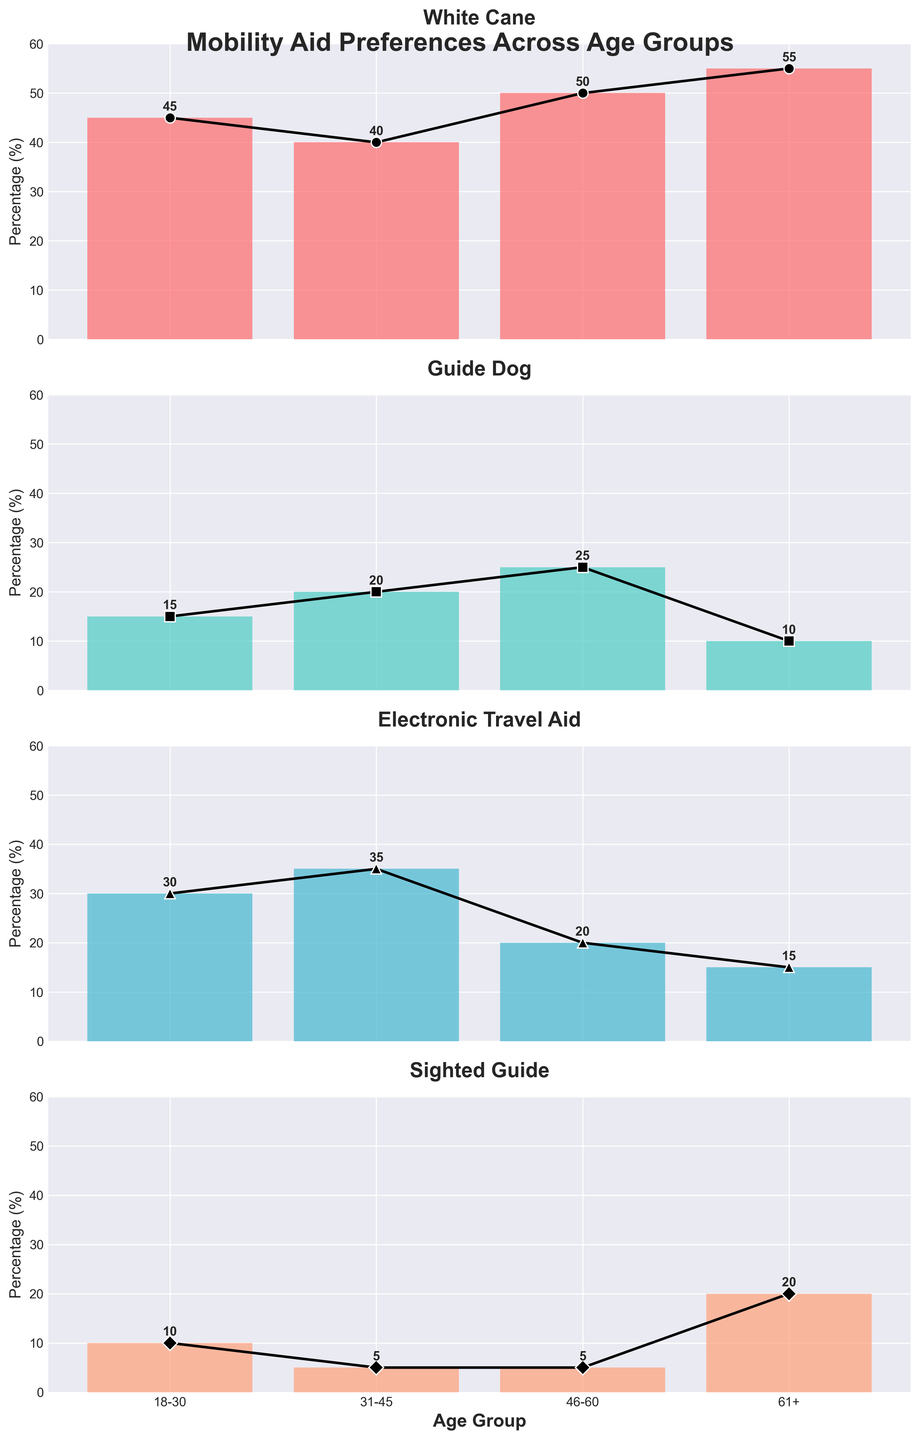What are the titles of the subplots in the figure? Each subplot has its own title indicating the type of mobility aid it represents. The titles are placed above each bar chart within the subplots. The titles are "White Cane", "Guide Dog", "Electronic Travel Aid", and "Sighted Guide".
Answer: White Cane, Guide Dog, Electronic Travel Aid, Sighted Guide What is the highest percentage for White Cane, and which age group does it belong to? The heights of the bars in the "White Cane" subplot represent the percentages for each age group. The highest bar visually corresponds to the 61+ age group with a value of 55%.
Answer: 55%, 61+ age group Which age group shows the lowest preference for Guide Dog, and what is the percentage? In the "Guide Dog" subplot, the shortest bar indicates the lowest percentage. This occurs in the 61+ age group with a value of 10%.
Answer: 61+ age group, 10% How does the preference for Electronic Travel Aid change from the 18-30 age group to the 61+ age group? Comparing the heights of the bars, the preference for Electronic Travel Aid starts at 30% for the 18-30 age group and decreases to 15% for the 61+ age group.
Answer: Decreases from 30% to 15% Which age group prefers Sighted Guide the most, and by what percentage? The "Sighted Guide" subplot's tallest bar belongs to the 61+ age group, with a value of 20%.
Answer: 61+ age group, 20% Summarize the trend of White Cane preference across all age groups. By analyzing the heights of the bars in the "White Cane" subplot, the preference for White Cane consistently increases with age, starting from 45% in the 18-30 age group to 55% in the 61+ age group.
Answer: Increases with age Calculate the average percentage preference for Guide Dog across all age groups. The percentages for Guide Dog are 15%, 20%, 25%, and 10%. To find the average, sum them up (15 + 20 + 25 + 10 = 70) and divide by the number of age groups (4): 70 / 4 = 17.5%.
Answer: 17.5% Compare the preference for White Cane and Guide Dog in the 31-45 age group. For the 31-45 age group, the White Cane preference is represented by a bar with a height of 40%, while the Guide Dog preference is shown by a bar with a height of 20%. Therefore, White Cane is preferred more than Guide Dog in this age group.
Answer: White Cane is preferred more (40% vs 20%) Which mobility aid has the most significant variation in preference across all age groups? Assessing the range of the bar heights in each subplot, the "Guide Dog" has the most significant variation, ranging from 10% (61+ age group) to 25% (46-60 age group), a difference of 15%.
Answer: Guide Dog 